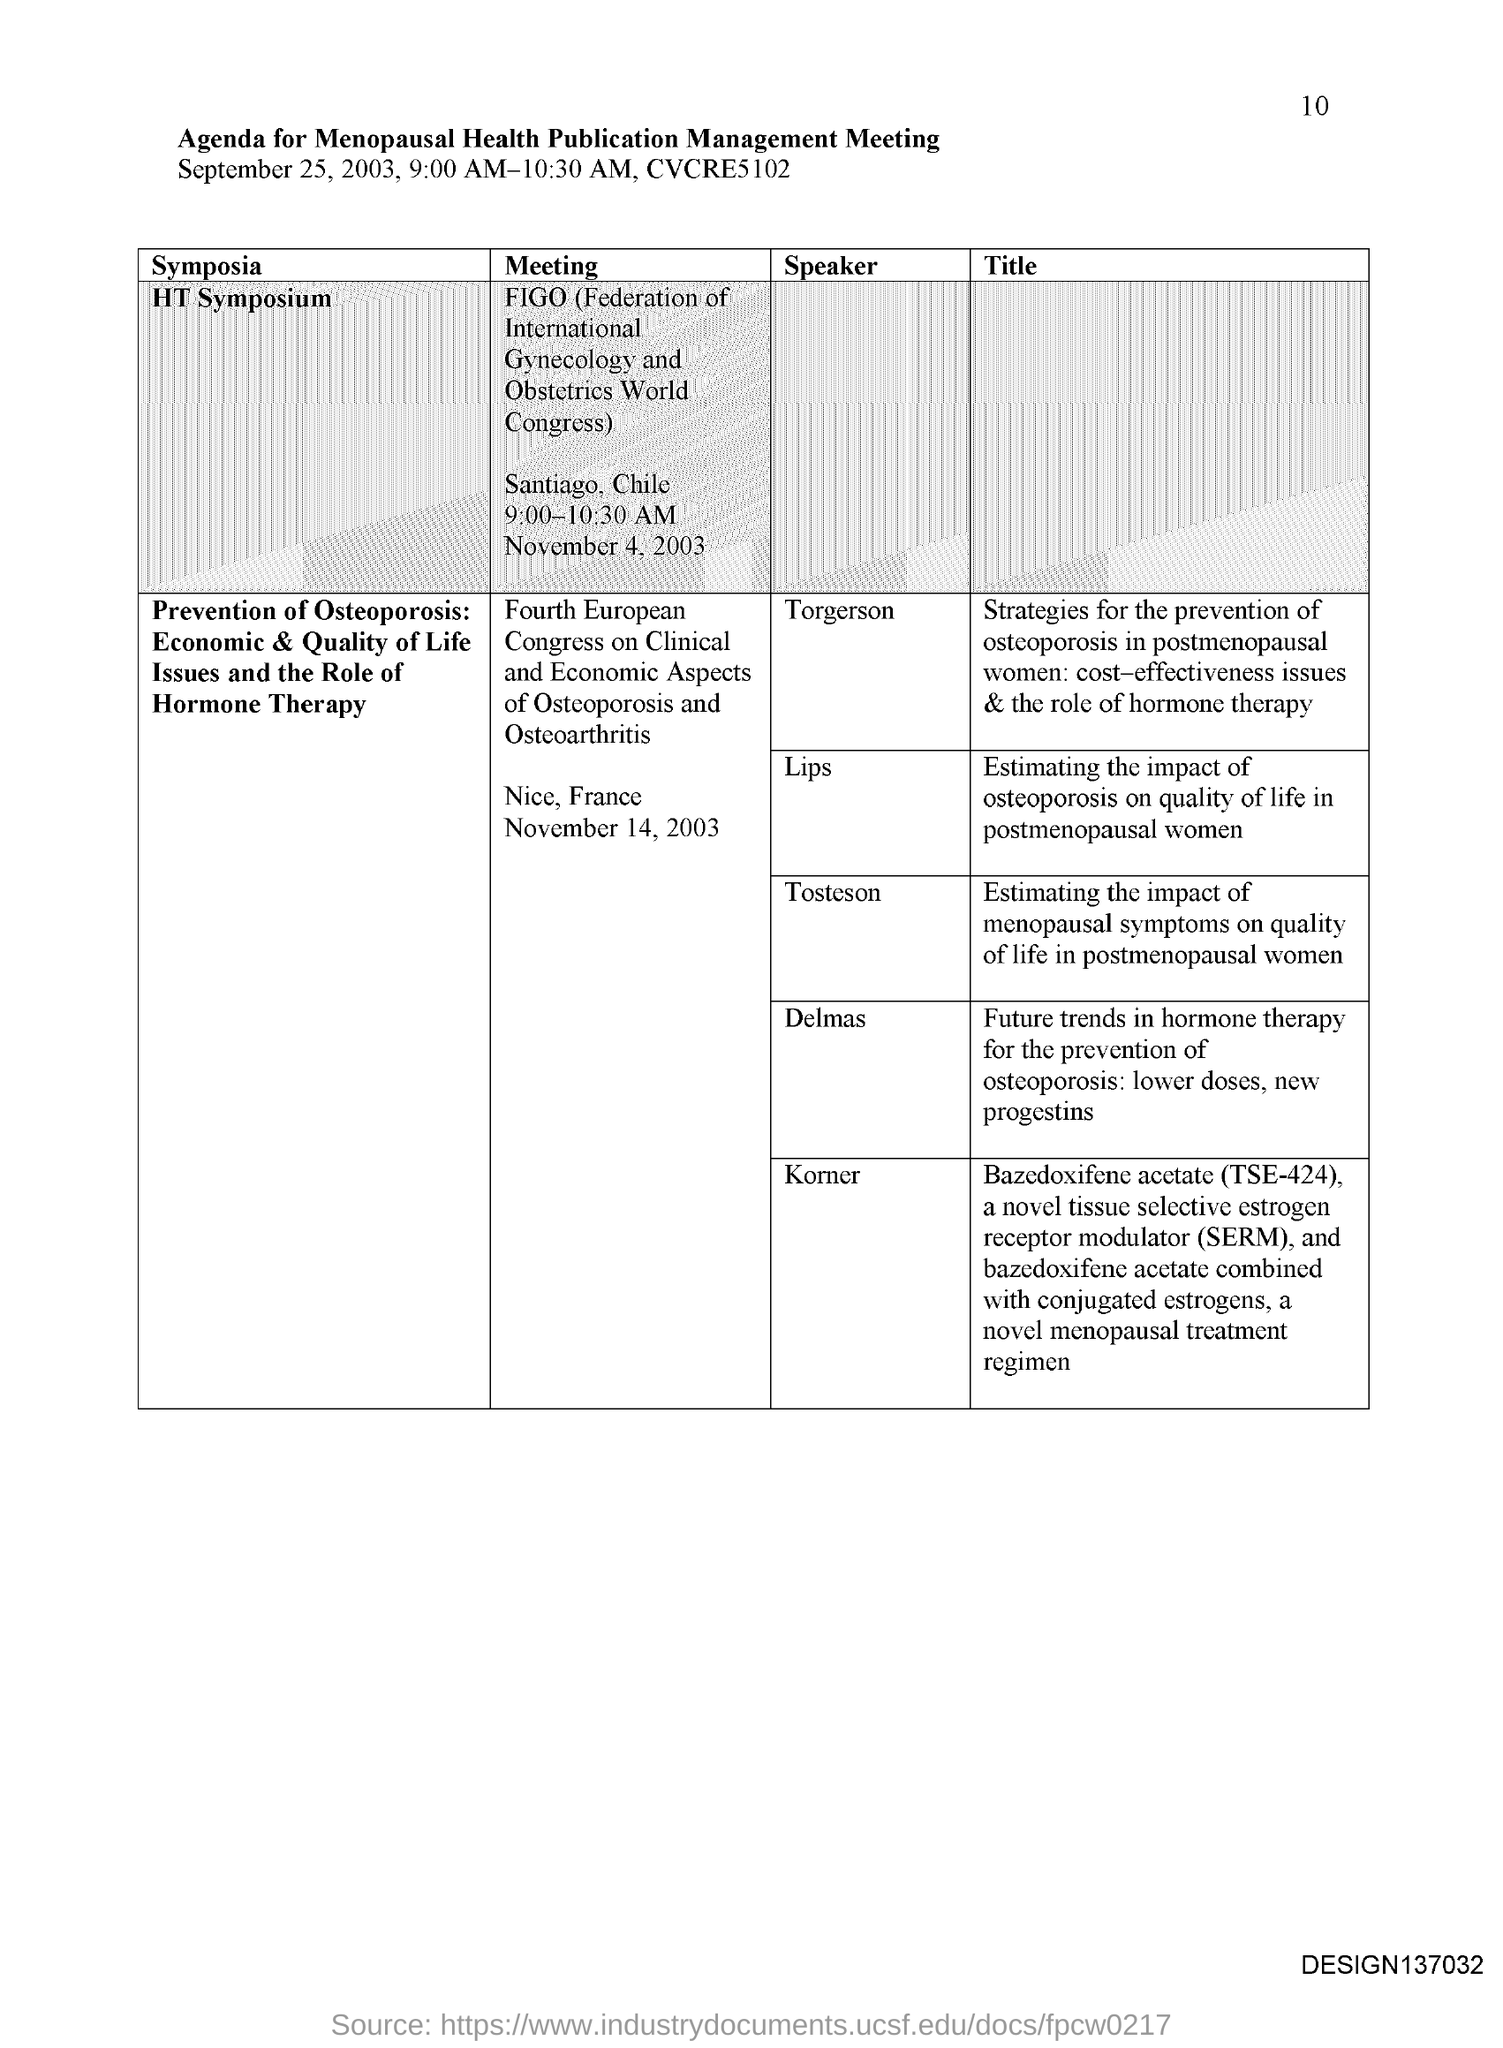What is the Page Number?
Ensure brevity in your answer.  10. What is the title of the document?
Offer a terse response. Agenda for Menopausal health publication management meeting. What is the full form of FIGO?
Your answer should be very brief. Federation of International Gynecology and Obstetrics World Congress. What is the full form of SERM?
Provide a succinct answer. Selective estrogen receptor modulator. 